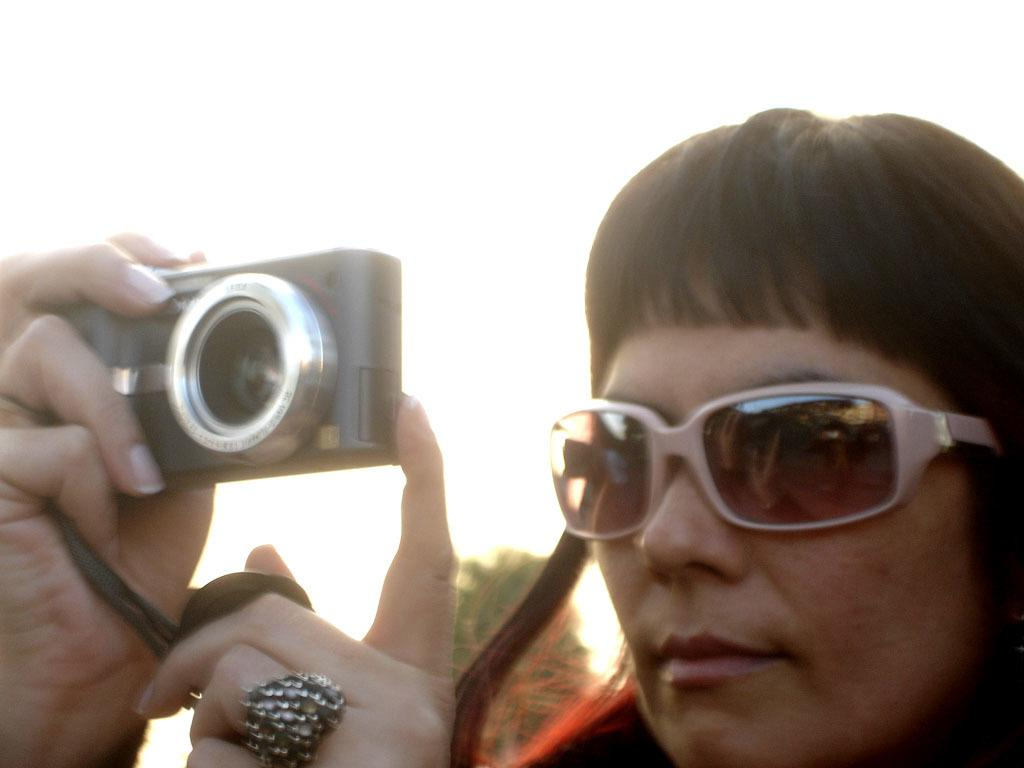What is the main subject of the image? There is a person in the image. What is the person holding in her hands? The person is holding a camera with her hands. What type of protective eyewear is the person wearing? The person is wearing goggles. What can be seen at the top of the image? The sky is visible at the top of the image. What type of voice can be heard coming from the border in the image? There is no border or voice present in the image; it features a person holding a camera and wearing goggles. 